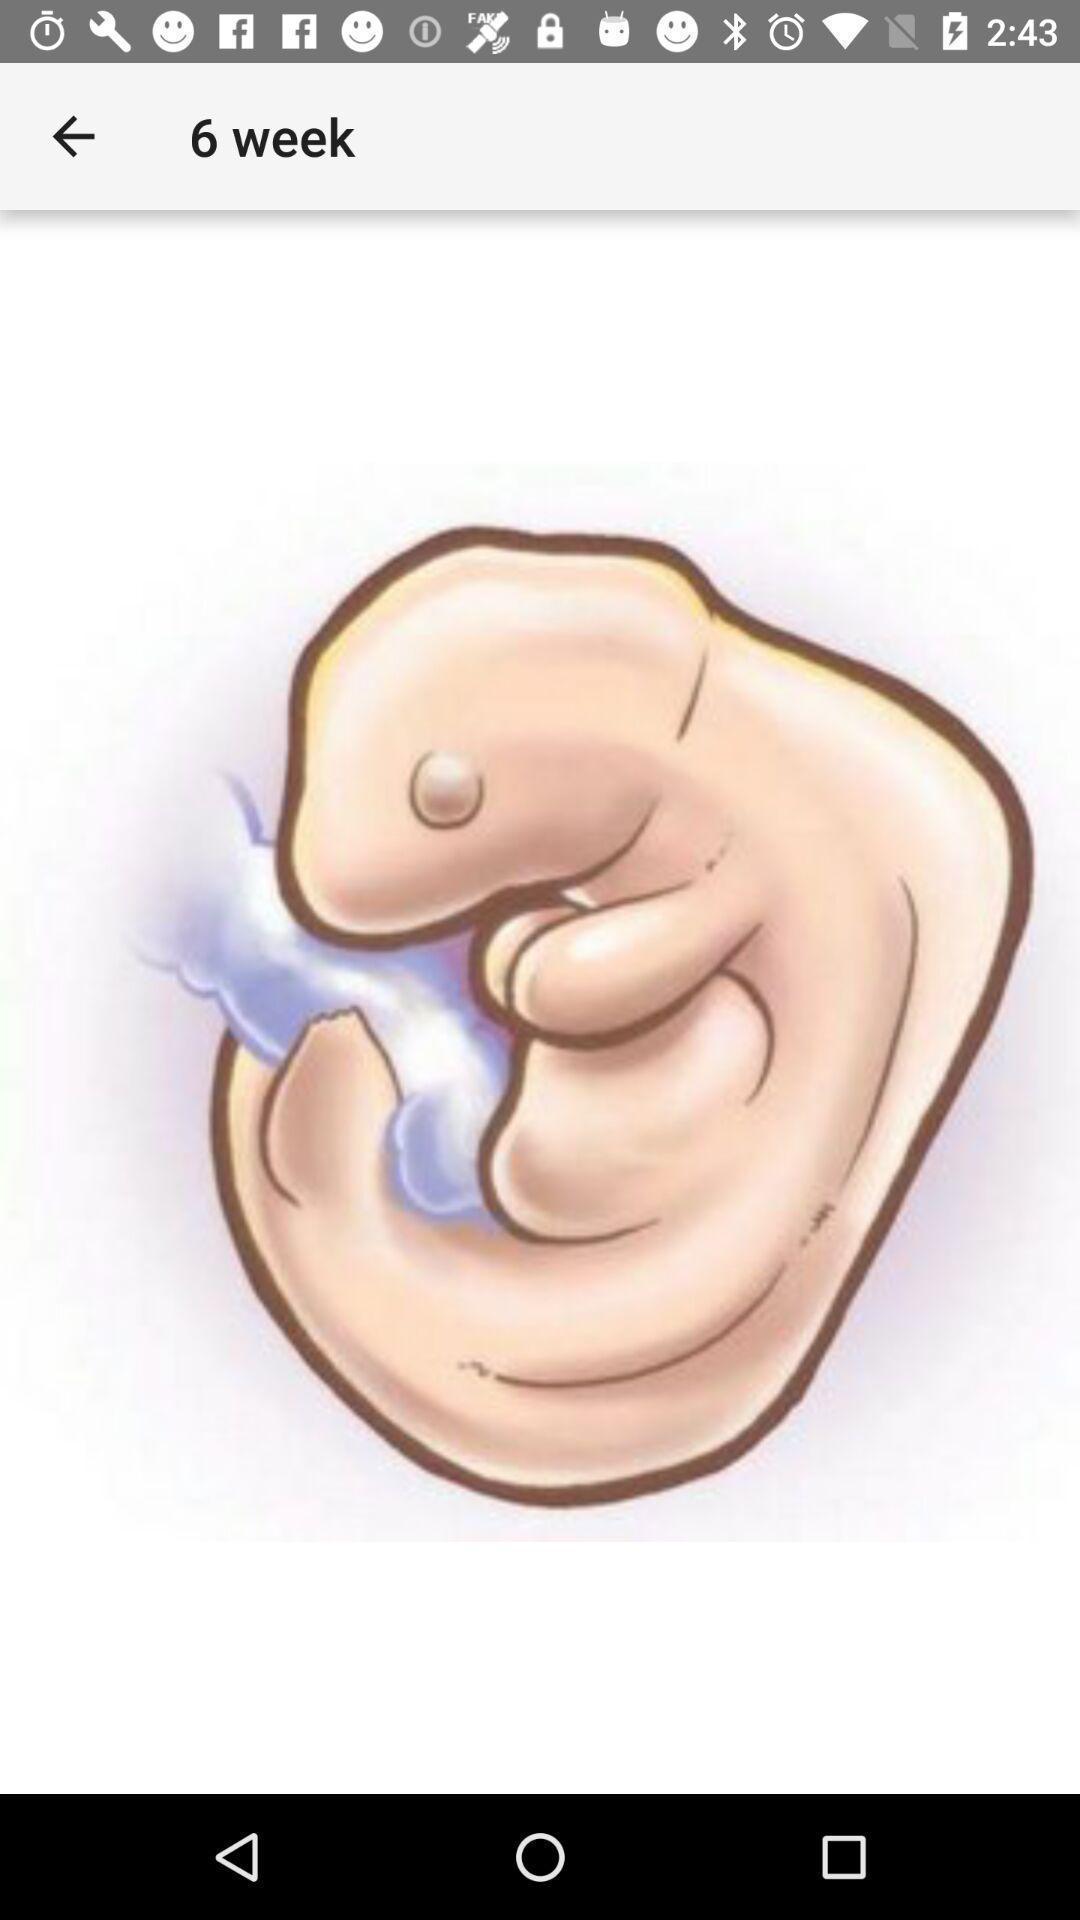Please provide a description for this image. Screen showing embryo size of week. 